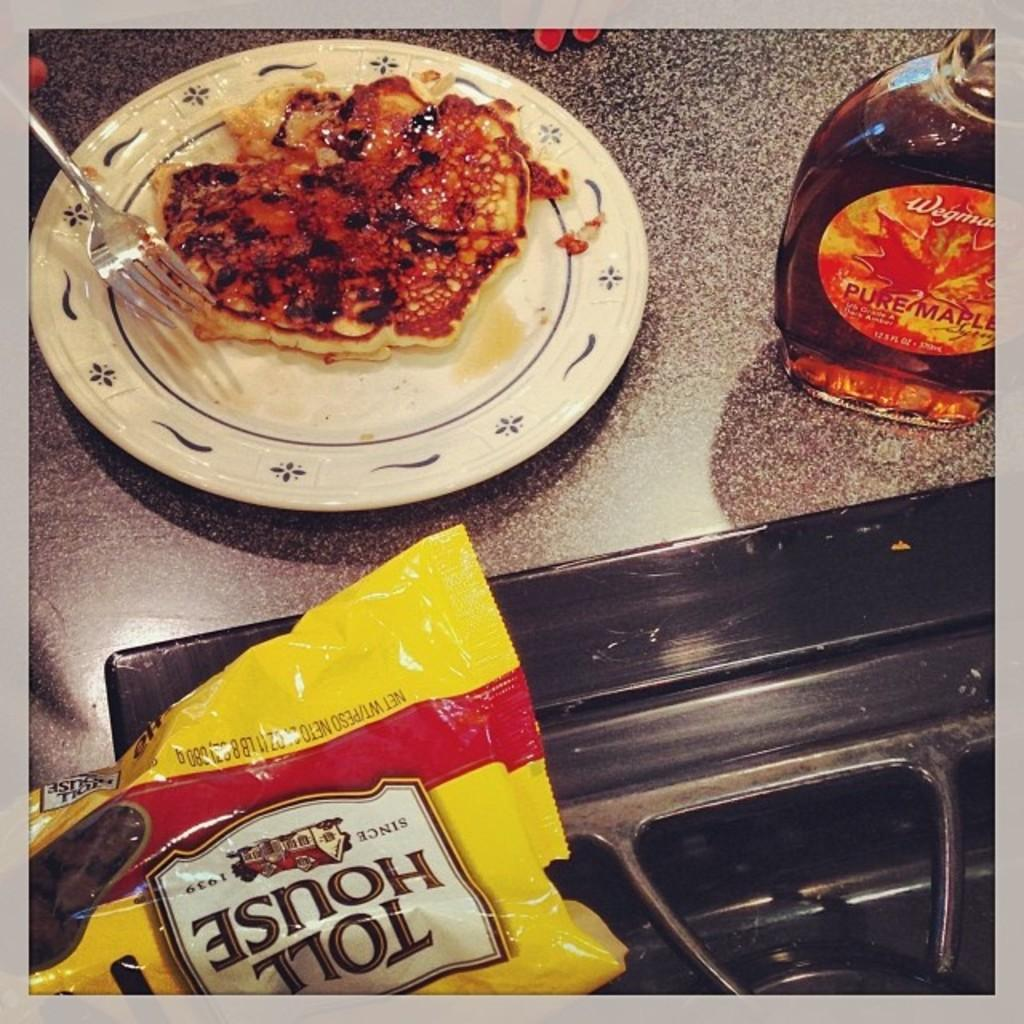What is covered or protected in the image? There is a cover in the image. What type of container is visible in the image? There is a bottle in the image. What color is the plate in the image? The plate in the image is white. What utensil is present in the image? There is a fork in the image. What is placed on the plate in the image? There is a dish on the plate in the image. Where is the zipper located on the plate in the image? There is no zipper present on the plate or in the image. What type of knee is visible in the image? There are no knees visible in the image; it features a cover, bottle, white plate, fork, and a dish on the plate. 